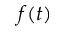<formula> <loc_0><loc_0><loc_500><loc_500>f ( t )</formula> 